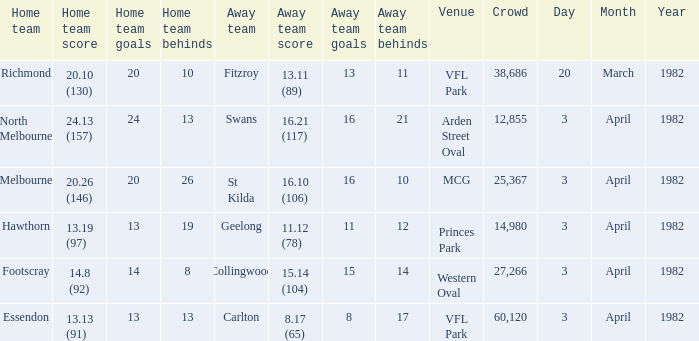What total did the north melbourne home team achieve? 24.13 (157). 